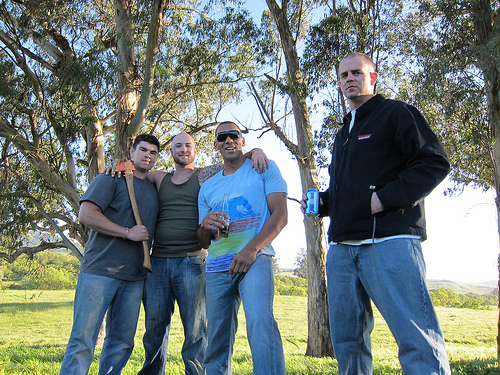<image>
Is the tattoo on the man? No. The tattoo is not positioned on the man. They may be near each other, but the tattoo is not supported by or resting on top of the man. Is there a man behind the can? Yes. From this viewpoint, the man is positioned behind the can, with the can partially or fully occluding the man. 